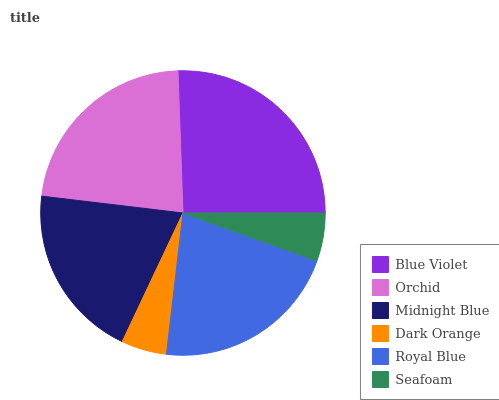Is Dark Orange the minimum?
Answer yes or no. Yes. Is Blue Violet the maximum?
Answer yes or no. Yes. Is Orchid the minimum?
Answer yes or no. No. Is Orchid the maximum?
Answer yes or no. No. Is Blue Violet greater than Orchid?
Answer yes or no. Yes. Is Orchid less than Blue Violet?
Answer yes or no. Yes. Is Orchid greater than Blue Violet?
Answer yes or no. No. Is Blue Violet less than Orchid?
Answer yes or no. No. Is Royal Blue the high median?
Answer yes or no. Yes. Is Midnight Blue the low median?
Answer yes or no. Yes. Is Seafoam the high median?
Answer yes or no. No. Is Dark Orange the low median?
Answer yes or no. No. 